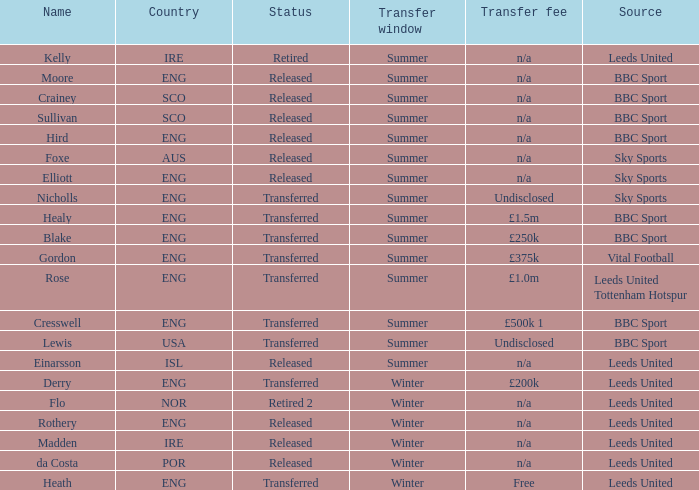What was the source for the person named Cresswell? BBC Sport. 